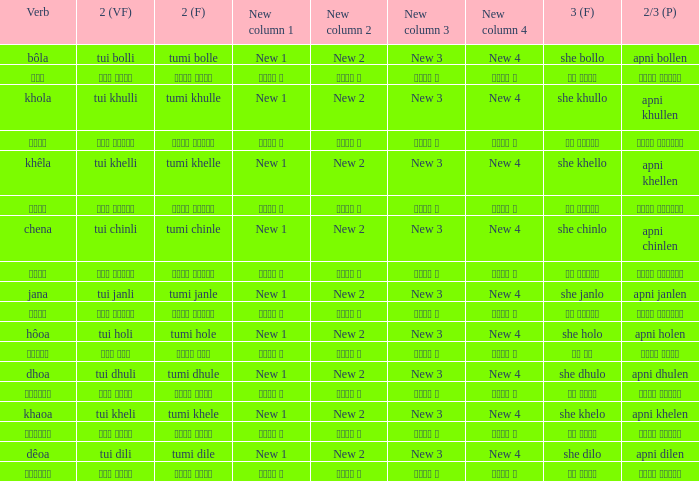What is the verb for তুমি খেলে? খাওয়া. 